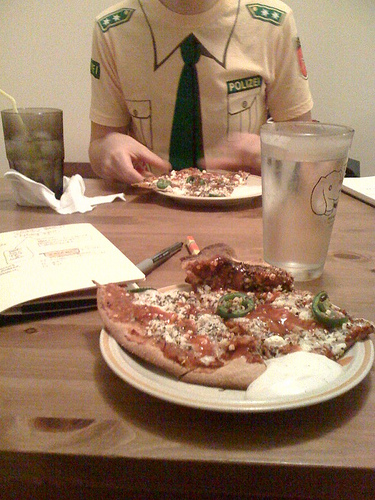What is the person wearing, and can you guess the context of their attire? The person in the image is wearing a shirt with badges, resembling a police uniform or possibly a costume. The context is not entirely clear, but it could be a costume party, a themed event, or the person's casual attire inspired by uniform style. 